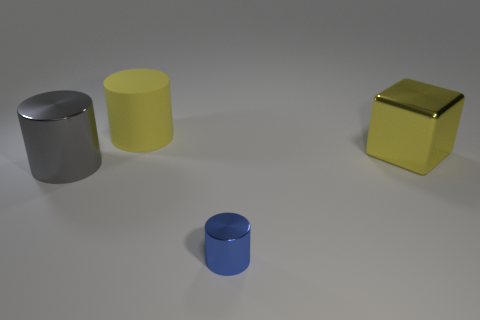Is there anything else that has the same size as the blue object?
Provide a succinct answer. No. Is there any other thing that has the same shape as the large yellow shiny object?
Give a very brief answer. No. The small shiny cylinder that is to the right of the yellow matte cylinder is what color?
Make the answer very short. Blue. Are there any shiny objects behind the large metal thing in front of the big thing that is to the right of the big yellow rubber object?
Your answer should be compact. Yes. Is the number of shiny cylinders that are on the right side of the big yellow rubber object greater than the number of large gray rubber blocks?
Your response must be concise. Yes. There is a big shiny thing on the left side of the rubber object; is it the same shape as the small blue object?
Your answer should be compact. Yes. Is there any other thing that is made of the same material as the big yellow cylinder?
Provide a succinct answer. No. How many objects are either big blue metallic things or shiny things that are on the left side of the blue object?
Offer a terse response. 1. There is a cylinder that is both in front of the yellow metallic thing and left of the tiny object; how big is it?
Ensure brevity in your answer.  Large. Are there more blue shiny objects on the right side of the gray object than blue metallic cylinders right of the blue metal cylinder?
Your response must be concise. Yes. 